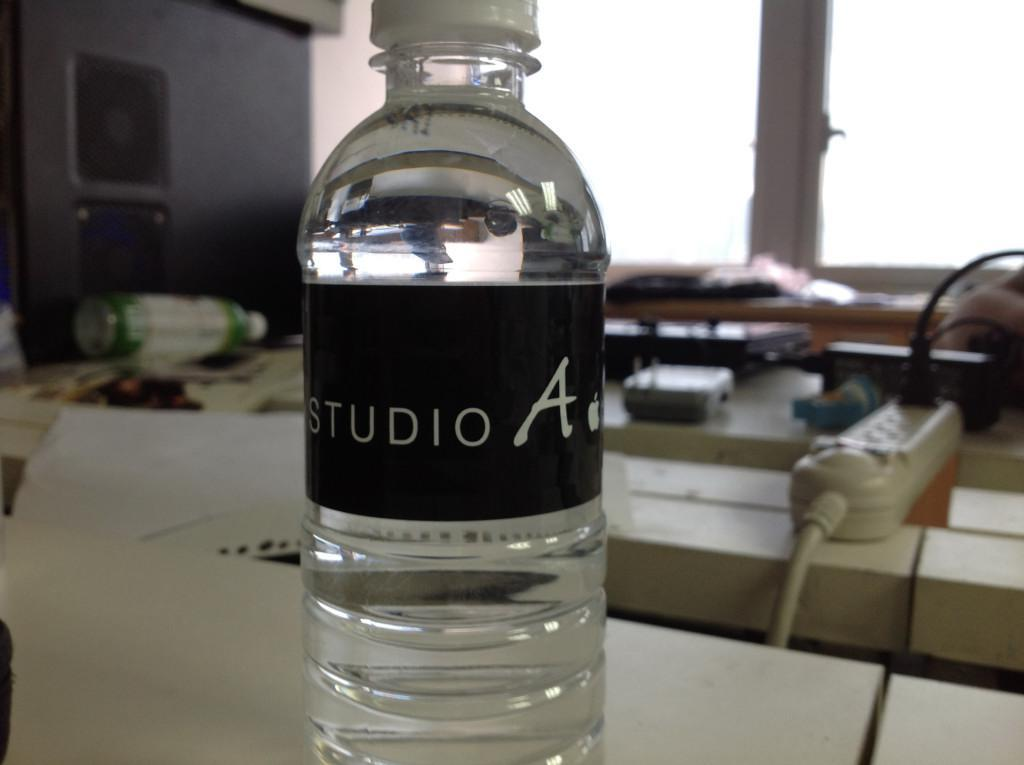<image>
Give a short and clear explanation of the subsequent image. A bottle of Studio A water sitting on a desk. 